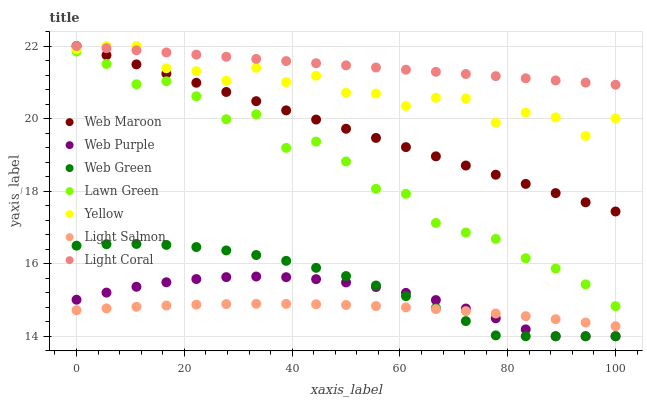Does Light Salmon have the minimum area under the curve?
Answer yes or no. Yes. Does Light Coral have the maximum area under the curve?
Answer yes or no. Yes. Does Web Maroon have the minimum area under the curve?
Answer yes or no. No. Does Web Maroon have the maximum area under the curve?
Answer yes or no. No. Is Web Maroon the smoothest?
Answer yes or no. Yes. Is Yellow the roughest?
Answer yes or no. Yes. Is Light Salmon the smoothest?
Answer yes or no. No. Is Light Salmon the roughest?
Answer yes or no. No. Does Web Purple have the lowest value?
Answer yes or no. Yes. Does Light Salmon have the lowest value?
Answer yes or no. No. Does Light Coral have the highest value?
Answer yes or no. Yes. Does Light Salmon have the highest value?
Answer yes or no. No. Is Light Salmon less than Yellow?
Answer yes or no. Yes. Is Web Maroon greater than Light Salmon?
Answer yes or no. Yes. Does Light Coral intersect Web Maroon?
Answer yes or no. Yes. Is Light Coral less than Web Maroon?
Answer yes or no. No. Is Light Coral greater than Web Maroon?
Answer yes or no. No. Does Light Salmon intersect Yellow?
Answer yes or no. No. 